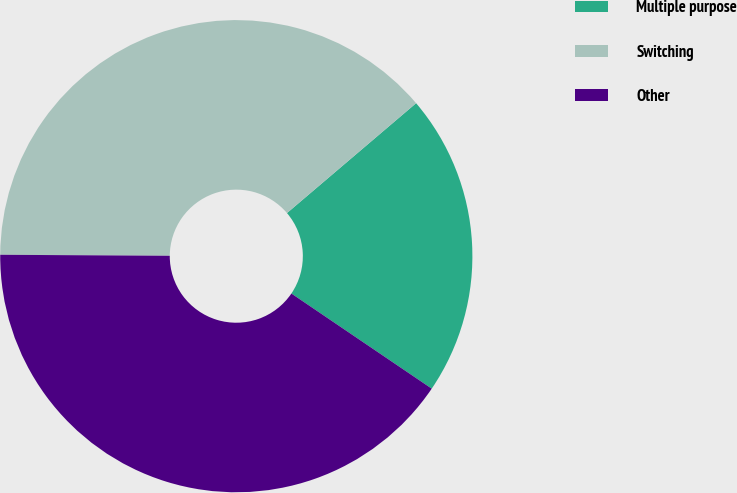<chart> <loc_0><loc_0><loc_500><loc_500><pie_chart><fcel>Multiple purpose<fcel>Switching<fcel>Other<nl><fcel>20.7%<fcel>38.68%<fcel>40.61%<nl></chart> 